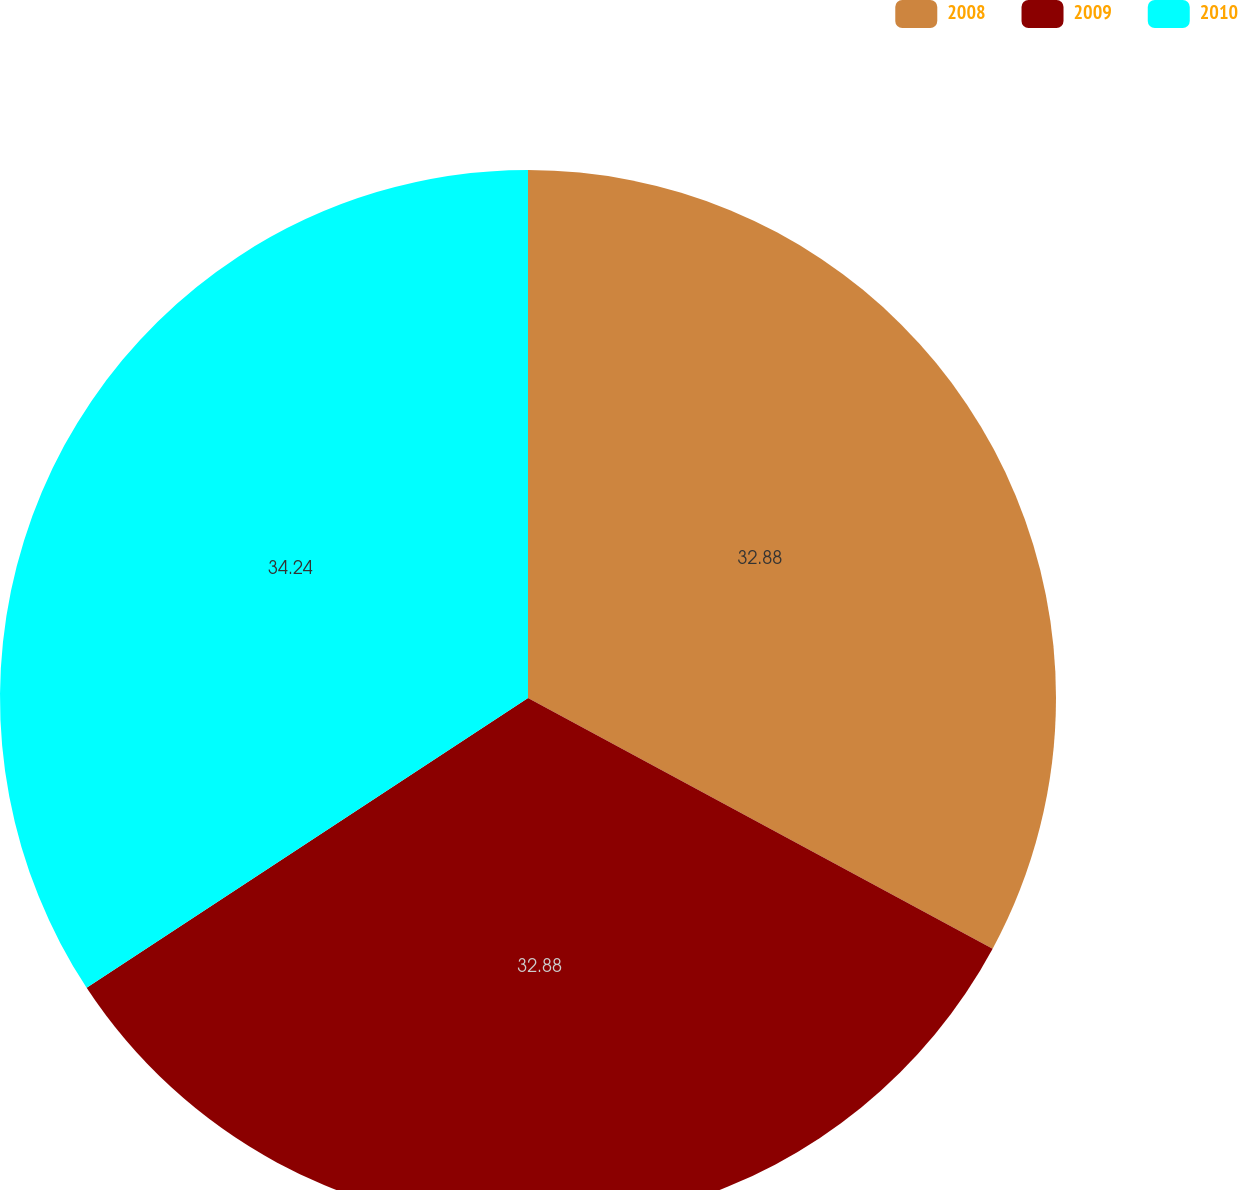<chart> <loc_0><loc_0><loc_500><loc_500><pie_chart><fcel>2008<fcel>2009<fcel>2010<nl><fcel>32.88%<fcel>32.88%<fcel>34.25%<nl></chart> 